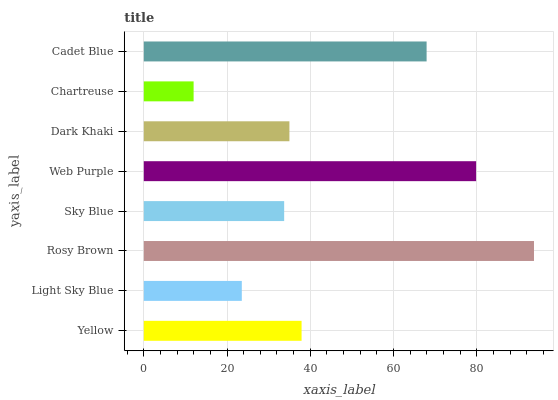Is Chartreuse the minimum?
Answer yes or no. Yes. Is Rosy Brown the maximum?
Answer yes or no. Yes. Is Light Sky Blue the minimum?
Answer yes or no. No. Is Light Sky Blue the maximum?
Answer yes or no. No. Is Yellow greater than Light Sky Blue?
Answer yes or no. Yes. Is Light Sky Blue less than Yellow?
Answer yes or no. Yes. Is Light Sky Blue greater than Yellow?
Answer yes or no. No. Is Yellow less than Light Sky Blue?
Answer yes or no. No. Is Yellow the high median?
Answer yes or no. Yes. Is Dark Khaki the low median?
Answer yes or no. Yes. Is Web Purple the high median?
Answer yes or no. No. Is Light Sky Blue the low median?
Answer yes or no. No. 